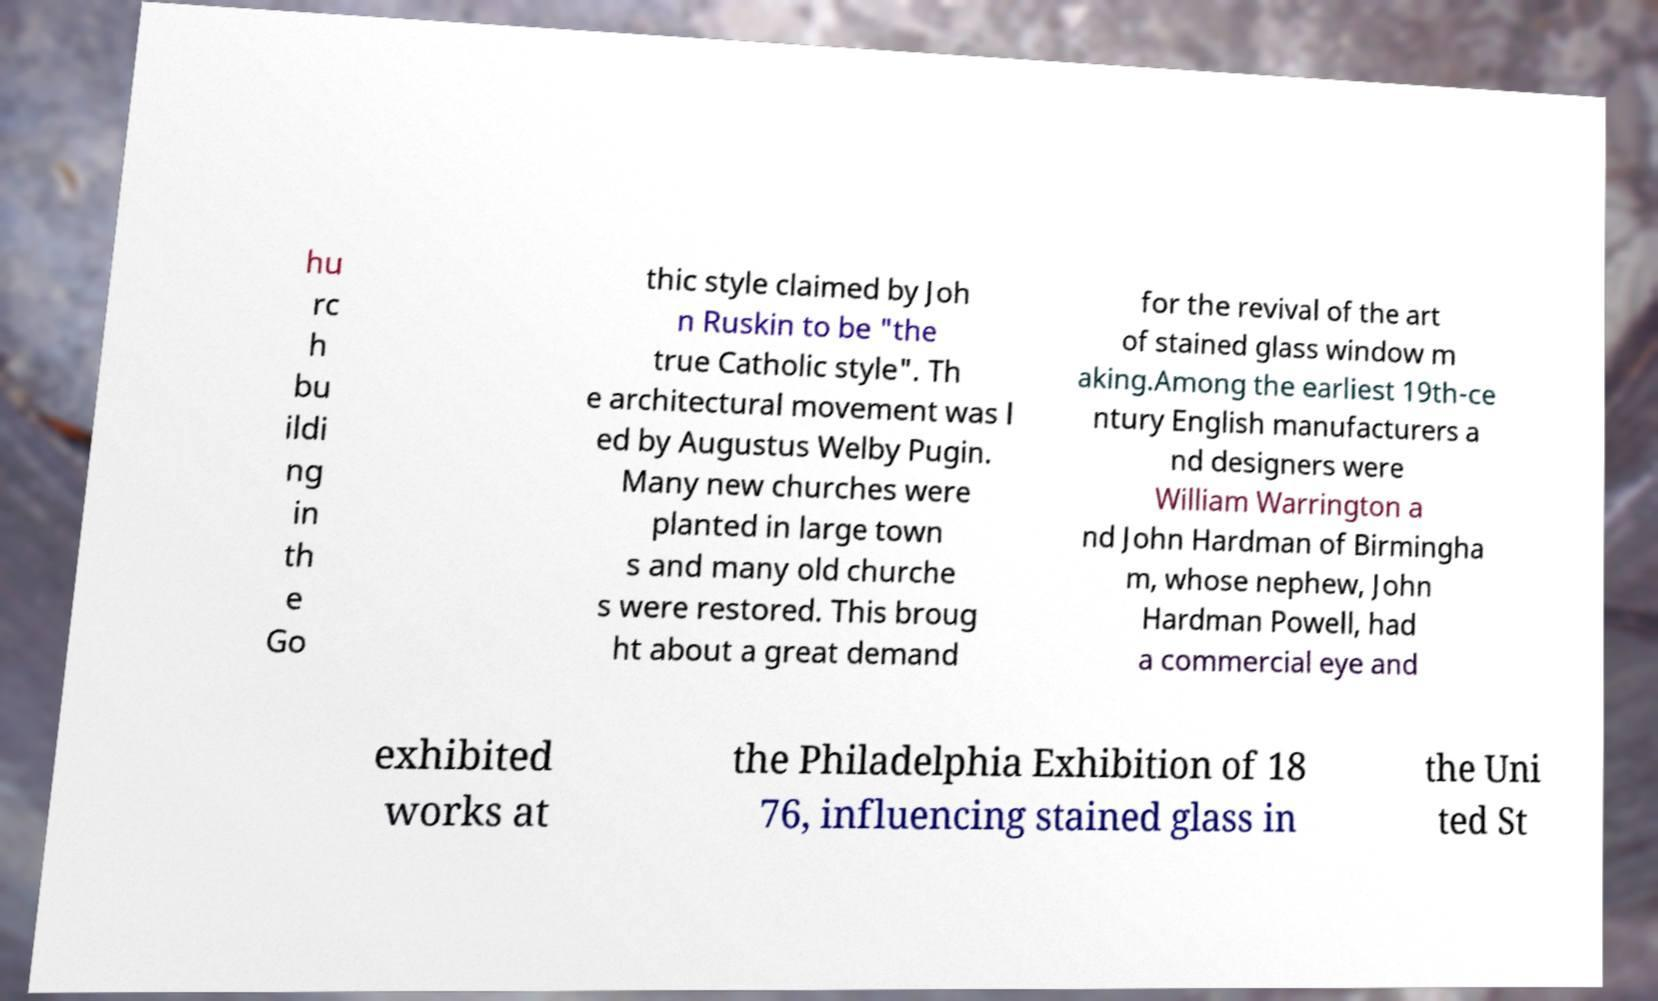What messages or text are displayed in this image? I need them in a readable, typed format. hu rc h bu ildi ng in th e Go thic style claimed by Joh n Ruskin to be "the true Catholic style". Th e architectural movement was l ed by Augustus Welby Pugin. Many new churches were planted in large town s and many old churche s were restored. This broug ht about a great demand for the revival of the art of stained glass window m aking.Among the earliest 19th-ce ntury English manufacturers a nd designers were William Warrington a nd John Hardman of Birmingha m, whose nephew, John Hardman Powell, had a commercial eye and exhibited works at the Philadelphia Exhibition of 18 76, influencing stained glass in the Uni ted St 